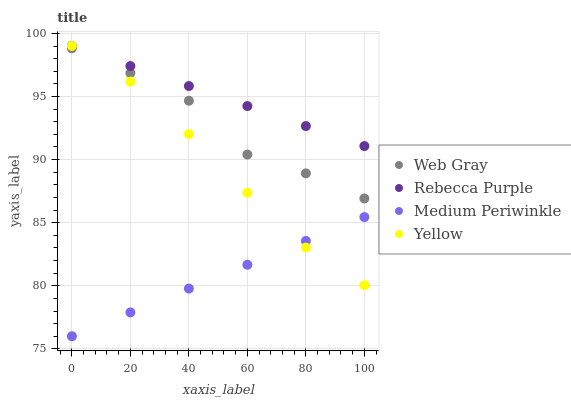Does Medium Periwinkle have the minimum area under the curve?
Answer yes or no. Yes. Does Rebecca Purple have the maximum area under the curve?
Answer yes or no. Yes. Does Rebecca Purple have the minimum area under the curve?
Answer yes or no. No. Does Medium Periwinkle have the maximum area under the curve?
Answer yes or no. No. Is Medium Periwinkle the smoothest?
Answer yes or no. Yes. Is Web Gray the roughest?
Answer yes or no. Yes. Is Rebecca Purple the smoothest?
Answer yes or no. No. Is Rebecca Purple the roughest?
Answer yes or no. No. Does Medium Periwinkle have the lowest value?
Answer yes or no. Yes. Does Rebecca Purple have the lowest value?
Answer yes or no. No. Does Yellow have the highest value?
Answer yes or no. Yes. Does Medium Periwinkle have the highest value?
Answer yes or no. No. Is Medium Periwinkle less than Rebecca Purple?
Answer yes or no. Yes. Is Web Gray greater than Medium Periwinkle?
Answer yes or no. Yes. Does Medium Periwinkle intersect Yellow?
Answer yes or no. Yes. Is Medium Periwinkle less than Yellow?
Answer yes or no. No. Is Medium Periwinkle greater than Yellow?
Answer yes or no. No. Does Medium Periwinkle intersect Rebecca Purple?
Answer yes or no. No. 